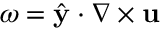<formula> <loc_0><loc_0><loc_500><loc_500>{ \omega = \hat { y } \cdot \nabla \times u }</formula> 